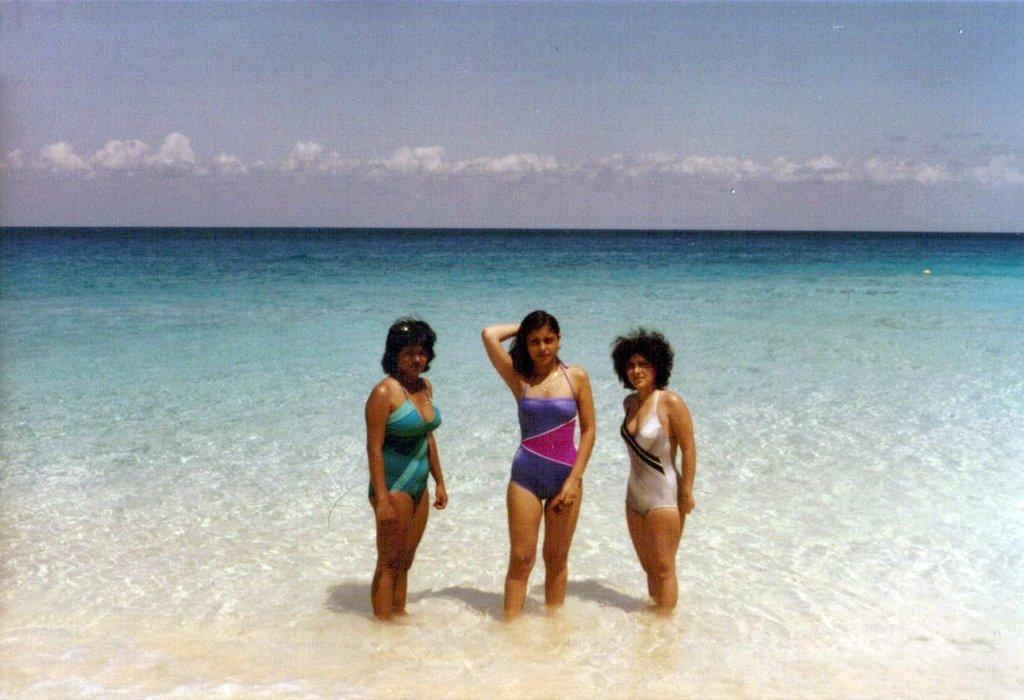What are the women in the image doing? The women are standing in the water in the center of the image. What can be seen in the background of the image? There is an ocean in the background of the image. How would you describe the sky in the image? The sky is cloudy in the image. What historical event is being commemorated by the women in the image? There is no indication of a historical event being commemorated in the image. 